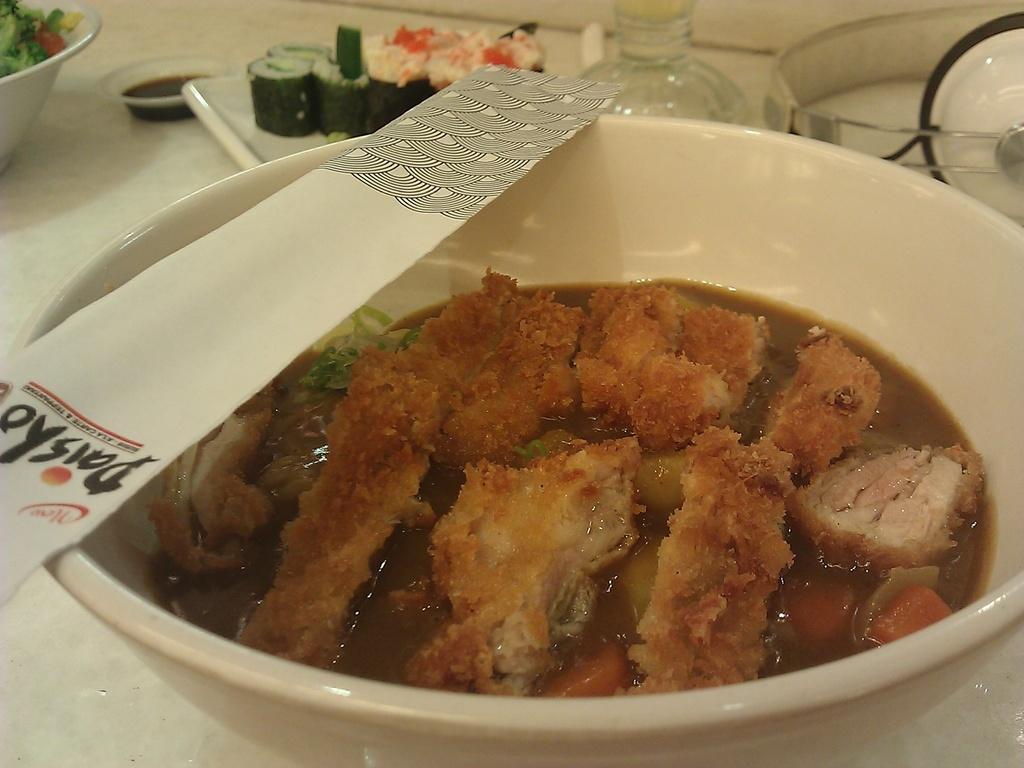Describe this image in one or two sentences. In this image there is a table and we can see a bowl containing food, sushi, bottled, salad and a plate placed on the table. 